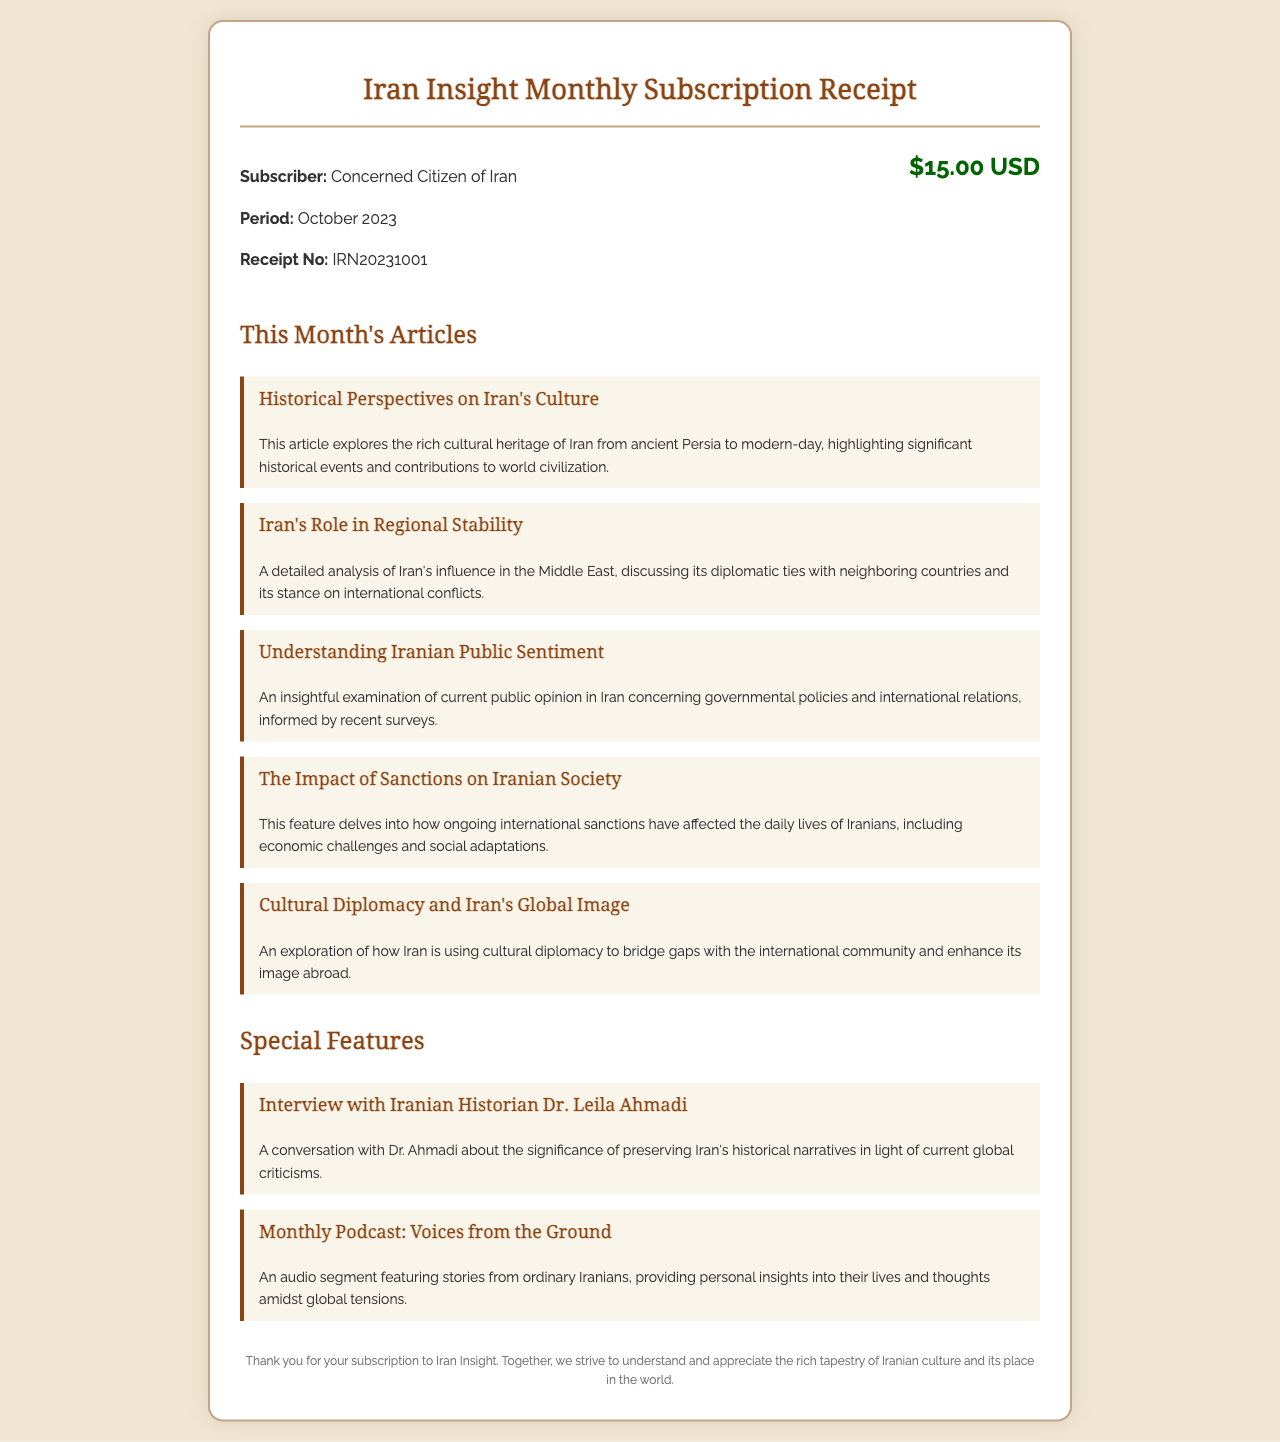What is the subscriber's name? The subscriber's name is provided in the document as "Concerned Citizen of Iran."
Answer: Concerned Citizen of Iran What is the receipt number? The receipt number is specified in the document under the receipt details section as "IRN20231001."
Answer: IRN20231001 What is the subscription period? The subscription period is mentioned in the document as "October 2023."
Answer: October 2023 How much is the subscription fee? The subscription fee is indicated prominently in the document as "$15.00 USD."
Answer: $15.00 USD What topic is explored in "Historical Perspectives on Iran's Culture"? The article discusses the rich cultural heritage of Iran from ancient Persia to modern-day.
Answer: Rich cultural heritage of Iran What is the focus of the special feature "Interview with Iranian Historian Dr. Leila Ahmadi"? The special feature centers on the significance of preserving Iran's historical narratives.
Answer: Preserving Iran's historical narratives What is the purpose of the monthly podcast mentioned? The podcast aims to provide personal insights into the lives of ordinary Iranians amidst global tensions.
Answer: Personal insights into their lives How many articles are listed in this month's receipt? The document lists a total of five articles under "This Month's Articles."
Answer: Five articles What is the title of the special feature discussing stories from ordinary Iranians? The title of the special feature is "Monthly Podcast: Voices from the Ground."
Answer: Monthly Podcast: Voices from the Ground 